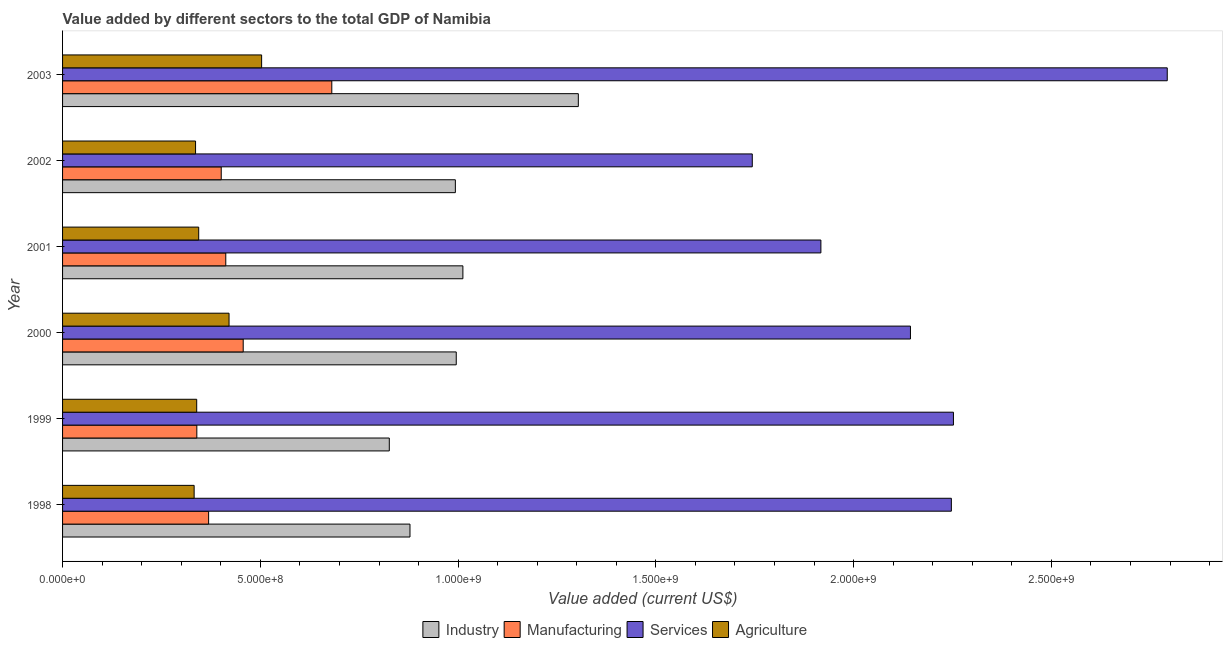How many different coloured bars are there?
Your answer should be very brief. 4. How many bars are there on the 5th tick from the top?
Make the answer very short. 4. How many bars are there on the 3rd tick from the bottom?
Your answer should be compact. 4. What is the label of the 4th group of bars from the top?
Offer a terse response. 2000. What is the value added by agricultural sector in 1999?
Ensure brevity in your answer.  3.39e+08. Across all years, what is the maximum value added by industrial sector?
Ensure brevity in your answer.  1.30e+09. Across all years, what is the minimum value added by manufacturing sector?
Your answer should be compact. 3.39e+08. In which year was the value added by services sector maximum?
Offer a terse response. 2003. What is the total value added by industrial sector in the graph?
Make the answer very short. 6.01e+09. What is the difference between the value added by industrial sector in 1998 and that in 2000?
Ensure brevity in your answer.  -1.17e+08. What is the difference between the value added by manufacturing sector in 1998 and the value added by services sector in 2002?
Offer a very short reply. -1.37e+09. What is the average value added by agricultural sector per year?
Give a very brief answer. 3.79e+08. In the year 1999, what is the difference between the value added by services sector and value added by agricultural sector?
Your response must be concise. 1.91e+09. What is the ratio of the value added by services sector in 1999 to that in 2000?
Your answer should be compact. 1.05. Is the value added by manufacturing sector in 1999 less than that in 2000?
Offer a terse response. Yes. Is the difference between the value added by industrial sector in 1999 and 2000 greater than the difference between the value added by agricultural sector in 1999 and 2000?
Provide a short and direct response. No. What is the difference between the highest and the second highest value added by services sector?
Ensure brevity in your answer.  5.41e+08. What is the difference between the highest and the lowest value added by agricultural sector?
Offer a terse response. 1.71e+08. Is it the case that in every year, the sum of the value added by agricultural sector and value added by services sector is greater than the sum of value added by manufacturing sector and value added by industrial sector?
Provide a short and direct response. Yes. What does the 2nd bar from the top in 2003 represents?
Your answer should be compact. Services. What does the 1st bar from the bottom in 1999 represents?
Provide a short and direct response. Industry. Is it the case that in every year, the sum of the value added by industrial sector and value added by manufacturing sector is greater than the value added by services sector?
Offer a very short reply. No. Are all the bars in the graph horizontal?
Ensure brevity in your answer.  Yes. What is the difference between two consecutive major ticks on the X-axis?
Provide a succinct answer. 5.00e+08. Are the values on the major ticks of X-axis written in scientific E-notation?
Give a very brief answer. Yes. How many legend labels are there?
Offer a very short reply. 4. How are the legend labels stacked?
Your response must be concise. Horizontal. What is the title of the graph?
Ensure brevity in your answer.  Value added by different sectors to the total GDP of Namibia. Does "HFC gas" appear as one of the legend labels in the graph?
Ensure brevity in your answer.  No. What is the label or title of the X-axis?
Provide a succinct answer. Value added (current US$). What is the Value added (current US$) in Industry in 1998?
Provide a short and direct response. 8.78e+08. What is the Value added (current US$) in Manufacturing in 1998?
Provide a succinct answer. 3.69e+08. What is the Value added (current US$) of Services in 1998?
Offer a terse response. 2.25e+09. What is the Value added (current US$) in Agriculture in 1998?
Keep it short and to the point. 3.33e+08. What is the Value added (current US$) in Industry in 1999?
Offer a terse response. 8.26e+08. What is the Value added (current US$) of Manufacturing in 1999?
Provide a short and direct response. 3.39e+08. What is the Value added (current US$) of Services in 1999?
Offer a very short reply. 2.25e+09. What is the Value added (current US$) of Agriculture in 1999?
Offer a terse response. 3.39e+08. What is the Value added (current US$) of Industry in 2000?
Your answer should be very brief. 9.95e+08. What is the Value added (current US$) of Manufacturing in 2000?
Make the answer very short. 4.57e+08. What is the Value added (current US$) of Services in 2000?
Make the answer very short. 2.14e+09. What is the Value added (current US$) in Agriculture in 2000?
Provide a short and direct response. 4.21e+08. What is the Value added (current US$) in Industry in 2001?
Offer a very short reply. 1.01e+09. What is the Value added (current US$) of Manufacturing in 2001?
Ensure brevity in your answer.  4.13e+08. What is the Value added (current US$) in Services in 2001?
Give a very brief answer. 1.92e+09. What is the Value added (current US$) of Agriculture in 2001?
Provide a succinct answer. 3.44e+08. What is the Value added (current US$) in Industry in 2002?
Give a very brief answer. 9.93e+08. What is the Value added (current US$) of Manufacturing in 2002?
Your response must be concise. 4.01e+08. What is the Value added (current US$) of Services in 2002?
Your answer should be very brief. 1.74e+09. What is the Value added (current US$) in Agriculture in 2002?
Your answer should be compact. 3.36e+08. What is the Value added (current US$) in Industry in 2003?
Offer a very short reply. 1.30e+09. What is the Value added (current US$) of Manufacturing in 2003?
Provide a short and direct response. 6.81e+08. What is the Value added (current US$) of Services in 2003?
Provide a short and direct response. 2.79e+09. What is the Value added (current US$) of Agriculture in 2003?
Provide a succinct answer. 5.03e+08. Across all years, what is the maximum Value added (current US$) in Industry?
Your answer should be compact. 1.30e+09. Across all years, what is the maximum Value added (current US$) of Manufacturing?
Ensure brevity in your answer.  6.81e+08. Across all years, what is the maximum Value added (current US$) in Services?
Provide a succinct answer. 2.79e+09. Across all years, what is the maximum Value added (current US$) in Agriculture?
Your answer should be compact. 5.03e+08. Across all years, what is the minimum Value added (current US$) of Industry?
Your answer should be very brief. 8.26e+08. Across all years, what is the minimum Value added (current US$) of Manufacturing?
Give a very brief answer. 3.39e+08. Across all years, what is the minimum Value added (current US$) of Services?
Provide a succinct answer. 1.74e+09. Across all years, what is the minimum Value added (current US$) in Agriculture?
Your answer should be very brief. 3.33e+08. What is the total Value added (current US$) in Industry in the graph?
Provide a succinct answer. 6.01e+09. What is the total Value added (current US$) of Manufacturing in the graph?
Offer a very short reply. 2.66e+09. What is the total Value added (current US$) of Services in the graph?
Offer a terse response. 1.31e+1. What is the total Value added (current US$) in Agriculture in the graph?
Provide a short and direct response. 2.28e+09. What is the difference between the Value added (current US$) in Industry in 1998 and that in 1999?
Provide a succinct answer. 5.23e+07. What is the difference between the Value added (current US$) of Manufacturing in 1998 and that in 1999?
Your response must be concise. 2.98e+07. What is the difference between the Value added (current US$) in Services in 1998 and that in 1999?
Provide a short and direct response. -5.25e+06. What is the difference between the Value added (current US$) in Agriculture in 1998 and that in 1999?
Offer a terse response. -6.48e+06. What is the difference between the Value added (current US$) of Industry in 1998 and that in 2000?
Give a very brief answer. -1.17e+08. What is the difference between the Value added (current US$) of Manufacturing in 1998 and that in 2000?
Make the answer very short. -8.74e+07. What is the difference between the Value added (current US$) of Services in 1998 and that in 2000?
Offer a very short reply. 1.03e+08. What is the difference between the Value added (current US$) in Agriculture in 1998 and that in 2000?
Offer a terse response. -8.83e+07. What is the difference between the Value added (current US$) of Industry in 1998 and that in 2001?
Provide a short and direct response. -1.34e+08. What is the difference between the Value added (current US$) of Manufacturing in 1998 and that in 2001?
Offer a terse response. -4.34e+07. What is the difference between the Value added (current US$) of Services in 1998 and that in 2001?
Offer a terse response. 3.30e+08. What is the difference between the Value added (current US$) in Agriculture in 1998 and that in 2001?
Make the answer very short. -1.15e+07. What is the difference between the Value added (current US$) of Industry in 1998 and that in 2002?
Your answer should be very brief. -1.15e+08. What is the difference between the Value added (current US$) of Manufacturing in 1998 and that in 2002?
Your response must be concise. -3.19e+07. What is the difference between the Value added (current US$) in Services in 1998 and that in 2002?
Your response must be concise. 5.03e+08. What is the difference between the Value added (current US$) in Agriculture in 1998 and that in 2002?
Offer a terse response. -3.59e+06. What is the difference between the Value added (current US$) of Industry in 1998 and that in 2003?
Offer a terse response. -4.26e+08. What is the difference between the Value added (current US$) in Manufacturing in 1998 and that in 2003?
Provide a short and direct response. -3.11e+08. What is the difference between the Value added (current US$) in Services in 1998 and that in 2003?
Your answer should be very brief. -5.46e+08. What is the difference between the Value added (current US$) of Agriculture in 1998 and that in 2003?
Make the answer very short. -1.71e+08. What is the difference between the Value added (current US$) in Industry in 1999 and that in 2000?
Ensure brevity in your answer.  -1.69e+08. What is the difference between the Value added (current US$) in Manufacturing in 1999 and that in 2000?
Your answer should be very brief. -1.17e+08. What is the difference between the Value added (current US$) of Services in 1999 and that in 2000?
Ensure brevity in your answer.  1.09e+08. What is the difference between the Value added (current US$) in Agriculture in 1999 and that in 2000?
Keep it short and to the point. -8.18e+07. What is the difference between the Value added (current US$) of Industry in 1999 and that in 2001?
Your answer should be compact. -1.86e+08. What is the difference between the Value added (current US$) in Manufacturing in 1999 and that in 2001?
Your answer should be compact. -7.32e+07. What is the difference between the Value added (current US$) of Services in 1999 and that in 2001?
Make the answer very short. 3.35e+08. What is the difference between the Value added (current US$) in Agriculture in 1999 and that in 2001?
Offer a terse response. -5.06e+06. What is the difference between the Value added (current US$) in Industry in 1999 and that in 2002?
Provide a succinct answer. -1.67e+08. What is the difference between the Value added (current US$) of Manufacturing in 1999 and that in 2002?
Your answer should be very brief. -6.17e+07. What is the difference between the Value added (current US$) of Services in 1999 and that in 2002?
Keep it short and to the point. 5.09e+08. What is the difference between the Value added (current US$) of Agriculture in 1999 and that in 2002?
Offer a very short reply. 2.90e+06. What is the difference between the Value added (current US$) of Industry in 1999 and that in 2003?
Provide a short and direct response. -4.78e+08. What is the difference between the Value added (current US$) in Manufacturing in 1999 and that in 2003?
Provide a succinct answer. -3.41e+08. What is the difference between the Value added (current US$) of Services in 1999 and that in 2003?
Offer a very short reply. -5.41e+08. What is the difference between the Value added (current US$) of Agriculture in 1999 and that in 2003?
Keep it short and to the point. -1.64e+08. What is the difference between the Value added (current US$) of Industry in 2000 and that in 2001?
Your answer should be compact. -1.68e+07. What is the difference between the Value added (current US$) in Manufacturing in 2000 and that in 2001?
Keep it short and to the point. 4.40e+07. What is the difference between the Value added (current US$) of Services in 2000 and that in 2001?
Your response must be concise. 2.26e+08. What is the difference between the Value added (current US$) of Agriculture in 2000 and that in 2001?
Your answer should be compact. 7.67e+07. What is the difference between the Value added (current US$) in Industry in 2000 and that in 2002?
Offer a terse response. 2.27e+06. What is the difference between the Value added (current US$) of Manufacturing in 2000 and that in 2002?
Provide a succinct answer. 5.56e+07. What is the difference between the Value added (current US$) in Services in 2000 and that in 2002?
Give a very brief answer. 4.00e+08. What is the difference between the Value added (current US$) in Agriculture in 2000 and that in 2002?
Offer a very short reply. 8.47e+07. What is the difference between the Value added (current US$) in Industry in 2000 and that in 2003?
Your response must be concise. -3.09e+08. What is the difference between the Value added (current US$) of Manufacturing in 2000 and that in 2003?
Offer a terse response. -2.24e+08. What is the difference between the Value added (current US$) of Services in 2000 and that in 2003?
Your answer should be compact. -6.49e+08. What is the difference between the Value added (current US$) of Agriculture in 2000 and that in 2003?
Your response must be concise. -8.24e+07. What is the difference between the Value added (current US$) in Industry in 2001 and that in 2002?
Provide a succinct answer. 1.91e+07. What is the difference between the Value added (current US$) of Manufacturing in 2001 and that in 2002?
Offer a terse response. 1.15e+07. What is the difference between the Value added (current US$) of Services in 2001 and that in 2002?
Keep it short and to the point. 1.73e+08. What is the difference between the Value added (current US$) of Agriculture in 2001 and that in 2002?
Your response must be concise. 7.96e+06. What is the difference between the Value added (current US$) in Industry in 2001 and that in 2003?
Make the answer very short. -2.92e+08. What is the difference between the Value added (current US$) in Manufacturing in 2001 and that in 2003?
Your response must be concise. -2.68e+08. What is the difference between the Value added (current US$) of Services in 2001 and that in 2003?
Offer a terse response. -8.76e+08. What is the difference between the Value added (current US$) of Agriculture in 2001 and that in 2003?
Provide a succinct answer. -1.59e+08. What is the difference between the Value added (current US$) of Industry in 2002 and that in 2003?
Ensure brevity in your answer.  -3.11e+08. What is the difference between the Value added (current US$) in Manufacturing in 2002 and that in 2003?
Provide a short and direct response. -2.80e+08. What is the difference between the Value added (current US$) of Services in 2002 and that in 2003?
Provide a short and direct response. -1.05e+09. What is the difference between the Value added (current US$) in Agriculture in 2002 and that in 2003?
Your answer should be very brief. -1.67e+08. What is the difference between the Value added (current US$) of Industry in 1998 and the Value added (current US$) of Manufacturing in 1999?
Provide a succinct answer. 5.39e+08. What is the difference between the Value added (current US$) in Industry in 1998 and the Value added (current US$) in Services in 1999?
Provide a succinct answer. -1.37e+09. What is the difference between the Value added (current US$) of Industry in 1998 and the Value added (current US$) of Agriculture in 1999?
Your answer should be compact. 5.39e+08. What is the difference between the Value added (current US$) in Manufacturing in 1998 and the Value added (current US$) in Services in 1999?
Offer a terse response. -1.88e+09. What is the difference between the Value added (current US$) in Manufacturing in 1998 and the Value added (current US$) in Agriculture in 1999?
Offer a very short reply. 3.01e+07. What is the difference between the Value added (current US$) in Services in 1998 and the Value added (current US$) in Agriculture in 1999?
Your response must be concise. 1.91e+09. What is the difference between the Value added (current US$) of Industry in 1998 and the Value added (current US$) of Manufacturing in 2000?
Your answer should be very brief. 4.22e+08. What is the difference between the Value added (current US$) of Industry in 1998 and the Value added (current US$) of Services in 2000?
Your response must be concise. -1.27e+09. What is the difference between the Value added (current US$) in Industry in 1998 and the Value added (current US$) in Agriculture in 2000?
Ensure brevity in your answer.  4.57e+08. What is the difference between the Value added (current US$) of Manufacturing in 1998 and the Value added (current US$) of Services in 2000?
Your answer should be compact. -1.77e+09. What is the difference between the Value added (current US$) in Manufacturing in 1998 and the Value added (current US$) in Agriculture in 2000?
Provide a succinct answer. -5.16e+07. What is the difference between the Value added (current US$) of Services in 1998 and the Value added (current US$) of Agriculture in 2000?
Ensure brevity in your answer.  1.83e+09. What is the difference between the Value added (current US$) of Industry in 1998 and the Value added (current US$) of Manufacturing in 2001?
Provide a succinct answer. 4.66e+08. What is the difference between the Value added (current US$) of Industry in 1998 and the Value added (current US$) of Services in 2001?
Your answer should be very brief. -1.04e+09. What is the difference between the Value added (current US$) in Industry in 1998 and the Value added (current US$) in Agriculture in 2001?
Make the answer very short. 5.34e+08. What is the difference between the Value added (current US$) of Manufacturing in 1998 and the Value added (current US$) of Services in 2001?
Keep it short and to the point. -1.55e+09. What is the difference between the Value added (current US$) in Manufacturing in 1998 and the Value added (current US$) in Agriculture in 2001?
Offer a terse response. 2.51e+07. What is the difference between the Value added (current US$) of Services in 1998 and the Value added (current US$) of Agriculture in 2001?
Offer a very short reply. 1.90e+09. What is the difference between the Value added (current US$) of Industry in 1998 and the Value added (current US$) of Manufacturing in 2002?
Your answer should be compact. 4.77e+08. What is the difference between the Value added (current US$) in Industry in 1998 and the Value added (current US$) in Services in 2002?
Offer a very short reply. -8.65e+08. What is the difference between the Value added (current US$) of Industry in 1998 and the Value added (current US$) of Agriculture in 2002?
Make the answer very short. 5.42e+08. What is the difference between the Value added (current US$) in Manufacturing in 1998 and the Value added (current US$) in Services in 2002?
Keep it short and to the point. -1.37e+09. What is the difference between the Value added (current US$) in Manufacturing in 1998 and the Value added (current US$) in Agriculture in 2002?
Your response must be concise. 3.30e+07. What is the difference between the Value added (current US$) in Services in 1998 and the Value added (current US$) in Agriculture in 2002?
Keep it short and to the point. 1.91e+09. What is the difference between the Value added (current US$) in Industry in 1998 and the Value added (current US$) in Manufacturing in 2003?
Your response must be concise. 1.98e+08. What is the difference between the Value added (current US$) in Industry in 1998 and the Value added (current US$) in Services in 2003?
Make the answer very short. -1.91e+09. What is the difference between the Value added (current US$) of Industry in 1998 and the Value added (current US$) of Agriculture in 2003?
Provide a succinct answer. 3.75e+08. What is the difference between the Value added (current US$) of Manufacturing in 1998 and the Value added (current US$) of Services in 2003?
Provide a short and direct response. -2.42e+09. What is the difference between the Value added (current US$) of Manufacturing in 1998 and the Value added (current US$) of Agriculture in 2003?
Keep it short and to the point. -1.34e+08. What is the difference between the Value added (current US$) in Services in 1998 and the Value added (current US$) in Agriculture in 2003?
Ensure brevity in your answer.  1.74e+09. What is the difference between the Value added (current US$) of Industry in 1999 and the Value added (current US$) of Manufacturing in 2000?
Keep it short and to the point. 3.69e+08. What is the difference between the Value added (current US$) of Industry in 1999 and the Value added (current US$) of Services in 2000?
Your answer should be very brief. -1.32e+09. What is the difference between the Value added (current US$) of Industry in 1999 and the Value added (current US$) of Agriculture in 2000?
Provide a succinct answer. 4.05e+08. What is the difference between the Value added (current US$) of Manufacturing in 1999 and the Value added (current US$) of Services in 2000?
Keep it short and to the point. -1.80e+09. What is the difference between the Value added (current US$) of Manufacturing in 1999 and the Value added (current US$) of Agriculture in 2000?
Offer a terse response. -8.15e+07. What is the difference between the Value added (current US$) in Services in 1999 and the Value added (current US$) in Agriculture in 2000?
Your response must be concise. 1.83e+09. What is the difference between the Value added (current US$) of Industry in 1999 and the Value added (current US$) of Manufacturing in 2001?
Keep it short and to the point. 4.13e+08. What is the difference between the Value added (current US$) of Industry in 1999 and the Value added (current US$) of Services in 2001?
Offer a terse response. -1.09e+09. What is the difference between the Value added (current US$) in Industry in 1999 and the Value added (current US$) in Agriculture in 2001?
Ensure brevity in your answer.  4.82e+08. What is the difference between the Value added (current US$) of Manufacturing in 1999 and the Value added (current US$) of Services in 2001?
Give a very brief answer. -1.58e+09. What is the difference between the Value added (current US$) in Manufacturing in 1999 and the Value added (current US$) in Agriculture in 2001?
Offer a very short reply. -4.77e+06. What is the difference between the Value added (current US$) of Services in 1999 and the Value added (current US$) of Agriculture in 2001?
Provide a short and direct response. 1.91e+09. What is the difference between the Value added (current US$) of Industry in 1999 and the Value added (current US$) of Manufacturing in 2002?
Offer a terse response. 4.25e+08. What is the difference between the Value added (current US$) of Industry in 1999 and the Value added (current US$) of Services in 2002?
Make the answer very short. -9.18e+08. What is the difference between the Value added (current US$) in Industry in 1999 and the Value added (current US$) in Agriculture in 2002?
Provide a succinct answer. 4.90e+08. What is the difference between the Value added (current US$) of Manufacturing in 1999 and the Value added (current US$) of Services in 2002?
Ensure brevity in your answer.  -1.40e+09. What is the difference between the Value added (current US$) in Manufacturing in 1999 and the Value added (current US$) in Agriculture in 2002?
Offer a very short reply. 3.19e+06. What is the difference between the Value added (current US$) of Services in 1999 and the Value added (current US$) of Agriculture in 2002?
Offer a terse response. 1.92e+09. What is the difference between the Value added (current US$) in Industry in 1999 and the Value added (current US$) in Manufacturing in 2003?
Provide a succinct answer. 1.45e+08. What is the difference between the Value added (current US$) of Industry in 1999 and the Value added (current US$) of Services in 2003?
Provide a succinct answer. -1.97e+09. What is the difference between the Value added (current US$) in Industry in 1999 and the Value added (current US$) in Agriculture in 2003?
Offer a very short reply. 3.23e+08. What is the difference between the Value added (current US$) of Manufacturing in 1999 and the Value added (current US$) of Services in 2003?
Provide a short and direct response. -2.45e+09. What is the difference between the Value added (current US$) in Manufacturing in 1999 and the Value added (current US$) in Agriculture in 2003?
Keep it short and to the point. -1.64e+08. What is the difference between the Value added (current US$) of Services in 1999 and the Value added (current US$) of Agriculture in 2003?
Your answer should be very brief. 1.75e+09. What is the difference between the Value added (current US$) of Industry in 2000 and the Value added (current US$) of Manufacturing in 2001?
Provide a short and direct response. 5.83e+08. What is the difference between the Value added (current US$) in Industry in 2000 and the Value added (current US$) in Services in 2001?
Keep it short and to the point. -9.22e+08. What is the difference between the Value added (current US$) in Industry in 2000 and the Value added (current US$) in Agriculture in 2001?
Offer a very short reply. 6.51e+08. What is the difference between the Value added (current US$) in Manufacturing in 2000 and the Value added (current US$) in Services in 2001?
Provide a short and direct response. -1.46e+09. What is the difference between the Value added (current US$) of Manufacturing in 2000 and the Value added (current US$) of Agriculture in 2001?
Ensure brevity in your answer.  1.12e+08. What is the difference between the Value added (current US$) of Services in 2000 and the Value added (current US$) of Agriculture in 2001?
Your response must be concise. 1.80e+09. What is the difference between the Value added (current US$) of Industry in 2000 and the Value added (current US$) of Manufacturing in 2002?
Offer a terse response. 5.94e+08. What is the difference between the Value added (current US$) of Industry in 2000 and the Value added (current US$) of Services in 2002?
Provide a short and direct response. -7.48e+08. What is the difference between the Value added (current US$) in Industry in 2000 and the Value added (current US$) in Agriculture in 2002?
Ensure brevity in your answer.  6.59e+08. What is the difference between the Value added (current US$) in Manufacturing in 2000 and the Value added (current US$) in Services in 2002?
Your answer should be compact. -1.29e+09. What is the difference between the Value added (current US$) in Manufacturing in 2000 and the Value added (current US$) in Agriculture in 2002?
Offer a terse response. 1.20e+08. What is the difference between the Value added (current US$) in Services in 2000 and the Value added (current US$) in Agriculture in 2002?
Offer a very short reply. 1.81e+09. What is the difference between the Value added (current US$) of Industry in 2000 and the Value added (current US$) of Manufacturing in 2003?
Your answer should be very brief. 3.15e+08. What is the difference between the Value added (current US$) of Industry in 2000 and the Value added (current US$) of Services in 2003?
Offer a terse response. -1.80e+09. What is the difference between the Value added (current US$) in Industry in 2000 and the Value added (current US$) in Agriculture in 2003?
Your answer should be very brief. 4.92e+08. What is the difference between the Value added (current US$) of Manufacturing in 2000 and the Value added (current US$) of Services in 2003?
Give a very brief answer. -2.34e+09. What is the difference between the Value added (current US$) of Manufacturing in 2000 and the Value added (current US$) of Agriculture in 2003?
Provide a short and direct response. -4.66e+07. What is the difference between the Value added (current US$) of Services in 2000 and the Value added (current US$) of Agriculture in 2003?
Provide a short and direct response. 1.64e+09. What is the difference between the Value added (current US$) in Industry in 2001 and the Value added (current US$) in Manufacturing in 2002?
Offer a terse response. 6.11e+08. What is the difference between the Value added (current US$) of Industry in 2001 and the Value added (current US$) of Services in 2002?
Offer a terse response. -7.32e+08. What is the difference between the Value added (current US$) of Industry in 2001 and the Value added (current US$) of Agriculture in 2002?
Provide a short and direct response. 6.76e+08. What is the difference between the Value added (current US$) of Manufacturing in 2001 and the Value added (current US$) of Services in 2002?
Provide a succinct answer. -1.33e+09. What is the difference between the Value added (current US$) in Manufacturing in 2001 and the Value added (current US$) in Agriculture in 2002?
Provide a short and direct response. 7.64e+07. What is the difference between the Value added (current US$) of Services in 2001 and the Value added (current US$) of Agriculture in 2002?
Make the answer very short. 1.58e+09. What is the difference between the Value added (current US$) of Industry in 2001 and the Value added (current US$) of Manufacturing in 2003?
Keep it short and to the point. 3.31e+08. What is the difference between the Value added (current US$) of Industry in 2001 and the Value added (current US$) of Services in 2003?
Keep it short and to the point. -1.78e+09. What is the difference between the Value added (current US$) in Industry in 2001 and the Value added (current US$) in Agriculture in 2003?
Provide a succinct answer. 5.09e+08. What is the difference between the Value added (current US$) of Manufacturing in 2001 and the Value added (current US$) of Services in 2003?
Your answer should be very brief. -2.38e+09. What is the difference between the Value added (current US$) in Manufacturing in 2001 and the Value added (current US$) in Agriculture in 2003?
Your answer should be very brief. -9.06e+07. What is the difference between the Value added (current US$) in Services in 2001 and the Value added (current US$) in Agriculture in 2003?
Make the answer very short. 1.41e+09. What is the difference between the Value added (current US$) in Industry in 2002 and the Value added (current US$) in Manufacturing in 2003?
Provide a succinct answer. 3.12e+08. What is the difference between the Value added (current US$) in Industry in 2002 and the Value added (current US$) in Services in 2003?
Provide a succinct answer. -1.80e+09. What is the difference between the Value added (current US$) of Industry in 2002 and the Value added (current US$) of Agriculture in 2003?
Offer a very short reply. 4.90e+08. What is the difference between the Value added (current US$) in Manufacturing in 2002 and the Value added (current US$) in Services in 2003?
Your answer should be compact. -2.39e+09. What is the difference between the Value added (current US$) in Manufacturing in 2002 and the Value added (current US$) in Agriculture in 2003?
Give a very brief answer. -1.02e+08. What is the difference between the Value added (current US$) of Services in 2002 and the Value added (current US$) of Agriculture in 2003?
Offer a terse response. 1.24e+09. What is the average Value added (current US$) in Industry per year?
Ensure brevity in your answer.  1.00e+09. What is the average Value added (current US$) in Manufacturing per year?
Ensure brevity in your answer.  4.43e+08. What is the average Value added (current US$) of Services per year?
Give a very brief answer. 2.18e+09. What is the average Value added (current US$) of Agriculture per year?
Your answer should be very brief. 3.79e+08. In the year 1998, what is the difference between the Value added (current US$) of Industry and Value added (current US$) of Manufacturing?
Your answer should be compact. 5.09e+08. In the year 1998, what is the difference between the Value added (current US$) in Industry and Value added (current US$) in Services?
Your response must be concise. -1.37e+09. In the year 1998, what is the difference between the Value added (current US$) in Industry and Value added (current US$) in Agriculture?
Make the answer very short. 5.46e+08. In the year 1998, what is the difference between the Value added (current US$) of Manufacturing and Value added (current US$) of Services?
Offer a very short reply. -1.88e+09. In the year 1998, what is the difference between the Value added (current US$) in Manufacturing and Value added (current US$) in Agriculture?
Your answer should be very brief. 3.66e+07. In the year 1998, what is the difference between the Value added (current US$) in Services and Value added (current US$) in Agriculture?
Offer a very short reply. 1.91e+09. In the year 1999, what is the difference between the Value added (current US$) of Industry and Value added (current US$) of Manufacturing?
Offer a terse response. 4.87e+08. In the year 1999, what is the difference between the Value added (current US$) of Industry and Value added (current US$) of Services?
Your answer should be compact. -1.43e+09. In the year 1999, what is the difference between the Value added (current US$) of Industry and Value added (current US$) of Agriculture?
Make the answer very short. 4.87e+08. In the year 1999, what is the difference between the Value added (current US$) of Manufacturing and Value added (current US$) of Services?
Keep it short and to the point. -1.91e+09. In the year 1999, what is the difference between the Value added (current US$) in Manufacturing and Value added (current US$) in Agriculture?
Your response must be concise. 2.93e+05. In the year 1999, what is the difference between the Value added (current US$) in Services and Value added (current US$) in Agriculture?
Ensure brevity in your answer.  1.91e+09. In the year 2000, what is the difference between the Value added (current US$) of Industry and Value added (current US$) of Manufacturing?
Offer a very short reply. 5.39e+08. In the year 2000, what is the difference between the Value added (current US$) of Industry and Value added (current US$) of Services?
Give a very brief answer. -1.15e+09. In the year 2000, what is the difference between the Value added (current US$) in Industry and Value added (current US$) in Agriculture?
Make the answer very short. 5.74e+08. In the year 2000, what is the difference between the Value added (current US$) of Manufacturing and Value added (current US$) of Services?
Provide a short and direct response. -1.69e+09. In the year 2000, what is the difference between the Value added (current US$) in Manufacturing and Value added (current US$) in Agriculture?
Your answer should be compact. 3.58e+07. In the year 2000, what is the difference between the Value added (current US$) of Services and Value added (current US$) of Agriculture?
Provide a short and direct response. 1.72e+09. In the year 2001, what is the difference between the Value added (current US$) of Industry and Value added (current US$) of Manufacturing?
Your answer should be very brief. 5.99e+08. In the year 2001, what is the difference between the Value added (current US$) of Industry and Value added (current US$) of Services?
Provide a succinct answer. -9.05e+08. In the year 2001, what is the difference between the Value added (current US$) in Industry and Value added (current US$) in Agriculture?
Give a very brief answer. 6.68e+08. In the year 2001, what is the difference between the Value added (current US$) of Manufacturing and Value added (current US$) of Services?
Make the answer very short. -1.50e+09. In the year 2001, what is the difference between the Value added (current US$) of Manufacturing and Value added (current US$) of Agriculture?
Offer a very short reply. 6.85e+07. In the year 2001, what is the difference between the Value added (current US$) in Services and Value added (current US$) in Agriculture?
Offer a very short reply. 1.57e+09. In the year 2002, what is the difference between the Value added (current US$) in Industry and Value added (current US$) in Manufacturing?
Ensure brevity in your answer.  5.92e+08. In the year 2002, what is the difference between the Value added (current US$) in Industry and Value added (current US$) in Services?
Keep it short and to the point. -7.51e+08. In the year 2002, what is the difference between the Value added (current US$) in Industry and Value added (current US$) in Agriculture?
Your answer should be very brief. 6.57e+08. In the year 2002, what is the difference between the Value added (current US$) of Manufacturing and Value added (current US$) of Services?
Offer a terse response. -1.34e+09. In the year 2002, what is the difference between the Value added (current US$) in Manufacturing and Value added (current US$) in Agriculture?
Your response must be concise. 6.49e+07. In the year 2002, what is the difference between the Value added (current US$) in Services and Value added (current US$) in Agriculture?
Give a very brief answer. 1.41e+09. In the year 2003, what is the difference between the Value added (current US$) of Industry and Value added (current US$) of Manufacturing?
Offer a very short reply. 6.23e+08. In the year 2003, what is the difference between the Value added (current US$) of Industry and Value added (current US$) of Services?
Make the answer very short. -1.49e+09. In the year 2003, what is the difference between the Value added (current US$) of Industry and Value added (current US$) of Agriculture?
Ensure brevity in your answer.  8.01e+08. In the year 2003, what is the difference between the Value added (current US$) in Manufacturing and Value added (current US$) in Services?
Your answer should be compact. -2.11e+09. In the year 2003, what is the difference between the Value added (current US$) of Manufacturing and Value added (current US$) of Agriculture?
Your response must be concise. 1.77e+08. In the year 2003, what is the difference between the Value added (current US$) of Services and Value added (current US$) of Agriculture?
Provide a succinct answer. 2.29e+09. What is the ratio of the Value added (current US$) of Industry in 1998 to that in 1999?
Your answer should be compact. 1.06. What is the ratio of the Value added (current US$) in Manufacturing in 1998 to that in 1999?
Offer a very short reply. 1.09. What is the ratio of the Value added (current US$) of Services in 1998 to that in 1999?
Provide a succinct answer. 1. What is the ratio of the Value added (current US$) in Agriculture in 1998 to that in 1999?
Give a very brief answer. 0.98. What is the ratio of the Value added (current US$) in Industry in 1998 to that in 2000?
Ensure brevity in your answer.  0.88. What is the ratio of the Value added (current US$) in Manufacturing in 1998 to that in 2000?
Your response must be concise. 0.81. What is the ratio of the Value added (current US$) of Services in 1998 to that in 2000?
Ensure brevity in your answer.  1.05. What is the ratio of the Value added (current US$) in Agriculture in 1998 to that in 2000?
Ensure brevity in your answer.  0.79. What is the ratio of the Value added (current US$) of Industry in 1998 to that in 2001?
Offer a terse response. 0.87. What is the ratio of the Value added (current US$) in Manufacturing in 1998 to that in 2001?
Give a very brief answer. 0.89. What is the ratio of the Value added (current US$) in Services in 1998 to that in 2001?
Your response must be concise. 1.17. What is the ratio of the Value added (current US$) in Agriculture in 1998 to that in 2001?
Your response must be concise. 0.97. What is the ratio of the Value added (current US$) of Industry in 1998 to that in 2002?
Offer a very short reply. 0.88. What is the ratio of the Value added (current US$) in Manufacturing in 1998 to that in 2002?
Offer a very short reply. 0.92. What is the ratio of the Value added (current US$) in Services in 1998 to that in 2002?
Ensure brevity in your answer.  1.29. What is the ratio of the Value added (current US$) of Agriculture in 1998 to that in 2002?
Your answer should be very brief. 0.99. What is the ratio of the Value added (current US$) in Industry in 1998 to that in 2003?
Your answer should be compact. 0.67. What is the ratio of the Value added (current US$) in Manufacturing in 1998 to that in 2003?
Make the answer very short. 0.54. What is the ratio of the Value added (current US$) of Services in 1998 to that in 2003?
Ensure brevity in your answer.  0.8. What is the ratio of the Value added (current US$) of Agriculture in 1998 to that in 2003?
Keep it short and to the point. 0.66. What is the ratio of the Value added (current US$) of Industry in 1999 to that in 2000?
Provide a succinct answer. 0.83. What is the ratio of the Value added (current US$) in Manufacturing in 1999 to that in 2000?
Your response must be concise. 0.74. What is the ratio of the Value added (current US$) in Services in 1999 to that in 2000?
Offer a terse response. 1.05. What is the ratio of the Value added (current US$) in Agriculture in 1999 to that in 2000?
Offer a very short reply. 0.81. What is the ratio of the Value added (current US$) of Industry in 1999 to that in 2001?
Offer a very short reply. 0.82. What is the ratio of the Value added (current US$) of Manufacturing in 1999 to that in 2001?
Offer a very short reply. 0.82. What is the ratio of the Value added (current US$) in Services in 1999 to that in 2001?
Ensure brevity in your answer.  1.17. What is the ratio of the Value added (current US$) of Industry in 1999 to that in 2002?
Give a very brief answer. 0.83. What is the ratio of the Value added (current US$) of Manufacturing in 1999 to that in 2002?
Provide a short and direct response. 0.85. What is the ratio of the Value added (current US$) of Services in 1999 to that in 2002?
Offer a very short reply. 1.29. What is the ratio of the Value added (current US$) in Agriculture in 1999 to that in 2002?
Offer a very short reply. 1.01. What is the ratio of the Value added (current US$) in Industry in 1999 to that in 2003?
Your answer should be very brief. 0.63. What is the ratio of the Value added (current US$) of Manufacturing in 1999 to that in 2003?
Offer a very short reply. 0.5. What is the ratio of the Value added (current US$) in Services in 1999 to that in 2003?
Ensure brevity in your answer.  0.81. What is the ratio of the Value added (current US$) in Agriculture in 1999 to that in 2003?
Provide a succinct answer. 0.67. What is the ratio of the Value added (current US$) in Industry in 2000 to that in 2001?
Offer a very short reply. 0.98. What is the ratio of the Value added (current US$) of Manufacturing in 2000 to that in 2001?
Keep it short and to the point. 1.11. What is the ratio of the Value added (current US$) in Services in 2000 to that in 2001?
Ensure brevity in your answer.  1.12. What is the ratio of the Value added (current US$) in Agriculture in 2000 to that in 2001?
Your answer should be compact. 1.22. What is the ratio of the Value added (current US$) of Industry in 2000 to that in 2002?
Give a very brief answer. 1. What is the ratio of the Value added (current US$) in Manufacturing in 2000 to that in 2002?
Your answer should be compact. 1.14. What is the ratio of the Value added (current US$) in Services in 2000 to that in 2002?
Offer a terse response. 1.23. What is the ratio of the Value added (current US$) in Agriculture in 2000 to that in 2002?
Ensure brevity in your answer.  1.25. What is the ratio of the Value added (current US$) of Industry in 2000 to that in 2003?
Your answer should be very brief. 0.76. What is the ratio of the Value added (current US$) in Manufacturing in 2000 to that in 2003?
Give a very brief answer. 0.67. What is the ratio of the Value added (current US$) of Services in 2000 to that in 2003?
Your answer should be very brief. 0.77. What is the ratio of the Value added (current US$) of Agriculture in 2000 to that in 2003?
Provide a short and direct response. 0.84. What is the ratio of the Value added (current US$) of Industry in 2001 to that in 2002?
Ensure brevity in your answer.  1.02. What is the ratio of the Value added (current US$) in Manufacturing in 2001 to that in 2002?
Your answer should be compact. 1.03. What is the ratio of the Value added (current US$) of Services in 2001 to that in 2002?
Offer a very short reply. 1.1. What is the ratio of the Value added (current US$) of Agriculture in 2001 to that in 2002?
Offer a very short reply. 1.02. What is the ratio of the Value added (current US$) in Industry in 2001 to that in 2003?
Offer a terse response. 0.78. What is the ratio of the Value added (current US$) in Manufacturing in 2001 to that in 2003?
Your answer should be very brief. 0.61. What is the ratio of the Value added (current US$) in Services in 2001 to that in 2003?
Make the answer very short. 0.69. What is the ratio of the Value added (current US$) in Agriculture in 2001 to that in 2003?
Provide a short and direct response. 0.68. What is the ratio of the Value added (current US$) in Industry in 2002 to that in 2003?
Offer a terse response. 0.76. What is the ratio of the Value added (current US$) of Manufacturing in 2002 to that in 2003?
Your response must be concise. 0.59. What is the ratio of the Value added (current US$) in Services in 2002 to that in 2003?
Offer a very short reply. 0.62. What is the ratio of the Value added (current US$) of Agriculture in 2002 to that in 2003?
Offer a very short reply. 0.67. What is the difference between the highest and the second highest Value added (current US$) in Industry?
Offer a terse response. 2.92e+08. What is the difference between the highest and the second highest Value added (current US$) in Manufacturing?
Make the answer very short. 2.24e+08. What is the difference between the highest and the second highest Value added (current US$) of Services?
Keep it short and to the point. 5.41e+08. What is the difference between the highest and the second highest Value added (current US$) of Agriculture?
Your answer should be very brief. 8.24e+07. What is the difference between the highest and the lowest Value added (current US$) of Industry?
Provide a short and direct response. 4.78e+08. What is the difference between the highest and the lowest Value added (current US$) of Manufacturing?
Keep it short and to the point. 3.41e+08. What is the difference between the highest and the lowest Value added (current US$) of Services?
Your response must be concise. 1.05e+09. What is the difference between the highest and the lowest Value added (current US$) in Agriculture?
Keep it short and to the point. 1.71e+08. 